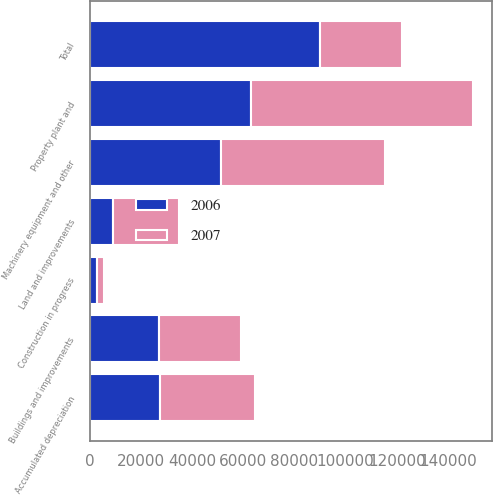<chart> <loc_0><loc_0><loc_500><loc_500><stacked_bar_chart><ecel><fcel>Land and improvements<fcel>Buildings and improvements<fcel>Machinery equipment and other<fcel>Construction in progress<fcel>Total<fcel>Accumulated depreciation<fcel>Property plant and<nl><fcel>2007<fcel>25695<fcel>32127<fcel>64112<fcel>2454<fcel>32127<fcel>37314<fcel>87074<nl><fcel>2006<fcel>9055<fcel>26967<fcel>51298<fcel>2809<fcel>90129<fcel>27278<fcel>62851<nl></chart> 